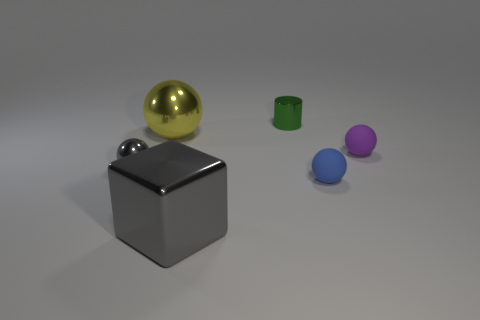Subtract all purple balls. How many balls are left? 3 Add 6 big blue metal cylinders. How many big blue metal cylinders exist? 6 Add 2 matte balls. How many objects exist? 8 Subtract all purple spheres. How many spheres are left? 3 Subtract 0 brown cubes. How many objects are left? 6 Subtract all cylinders. How many objects are left? 5 Subtract 1 spheres. How many spheres are left? 3 Subtract all gray cylinders. Subtract all green balls. How many cylinders are left? 1 Subtract all purple cylinders. How many gray balls are left? 1 Subtract all tiny gray metal cylinders. Subtract all yellow objects. How many objects are left? 5 